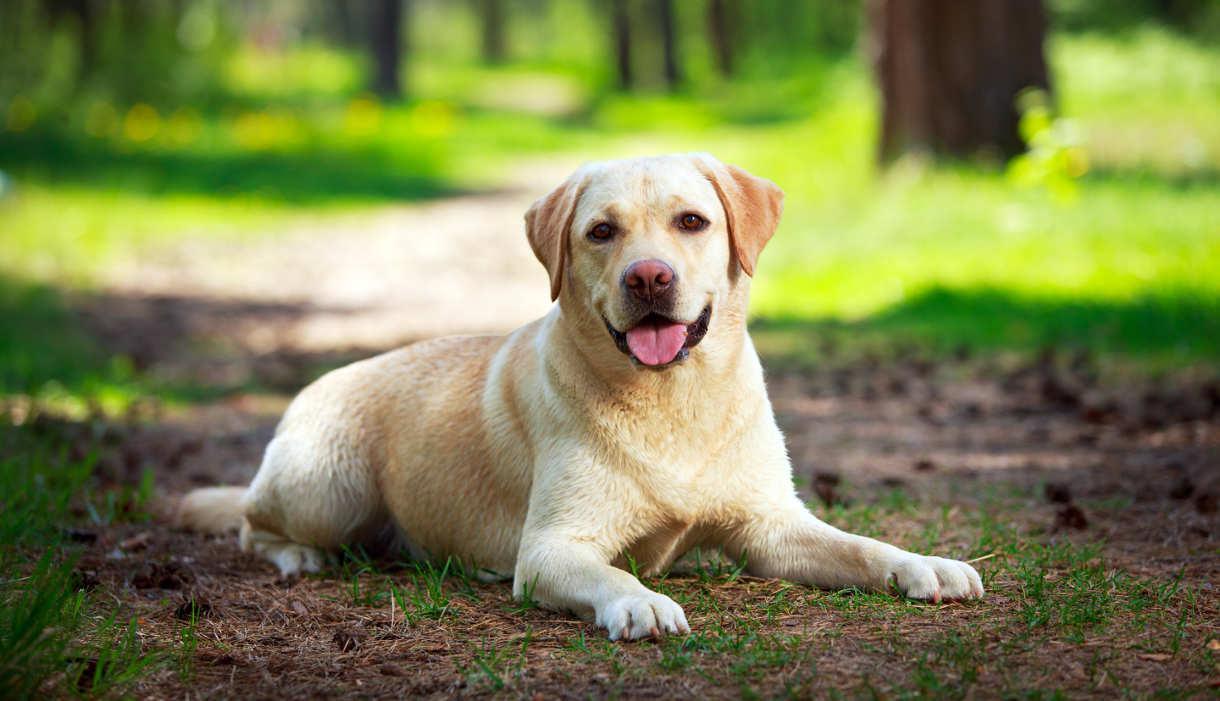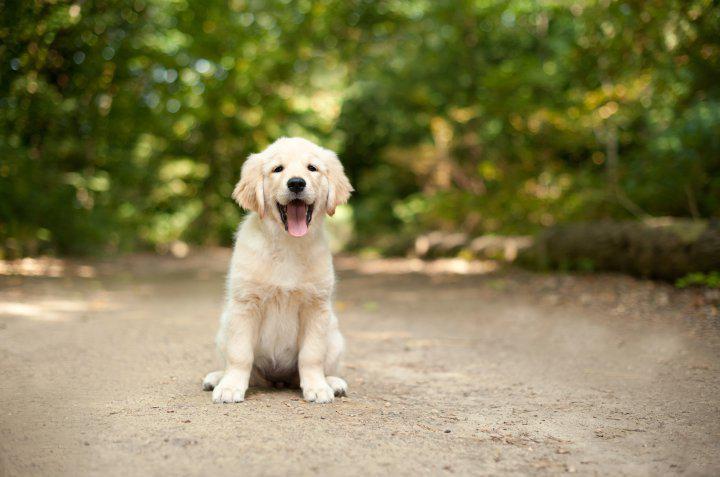The first image is the image on the left, the second image is the image on the right. Analyze the images presented: Is the assertion "In at least one image there are exactly two dogs outside together." valid? Answer yes or no. No. The first image is the image on the left, the second image is the image on the right. Examine the images to the left and right. Is the description "There are two dogs in the left picture." accurate? Answer yes or no. No. 